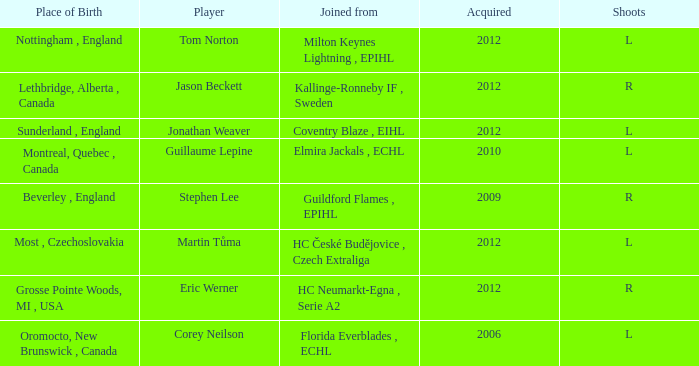I'm looking to parse the entire table for insights. Could you assist me with that? {'header': ['Place of Birth', 'Player', 'Joined from', 'Acquired', 'Shoots'], 'rows': [['Nottingham , England', 'Tom Norton', 'Milton Keynes Lightning , EPIHL', '2012', 'L'], ['Lethbridge, Alberta , Canada', 'Jason Beckett', 'Kallinge-Ronneby IF , Sweden', '2012', 'R'], ['Sunderland , England', 'Jonathan Weaver', 'Coventry Blaze , EIHL', '2012', 'L'], ['Montreal, Quebec , Canada', 'Guillaume Lepine', 'Elmira Jackals , ECHL', '2010', 'L'], ['Beverley , England', 'Stephen Lee', 'Guildford Flames , EPIHL', '2009', 'R'], ['Most , Czechoslovakia', 'Martin Tůma', 'HC České Budějovice , Czech Extraliga', '2012', 'L'], ['Grosse Pointe Woods, MI , USA', 'Eric Werner', 'HC Neumarkt-Egna , Serie A2', '2012', 'R'], ['Oromocto, New Brunswick , Canada', 'Corey Neilson', 'Florida Everblades , ECHL', '2006', 'L']]} Who acquired tom norton? 2012.0. 